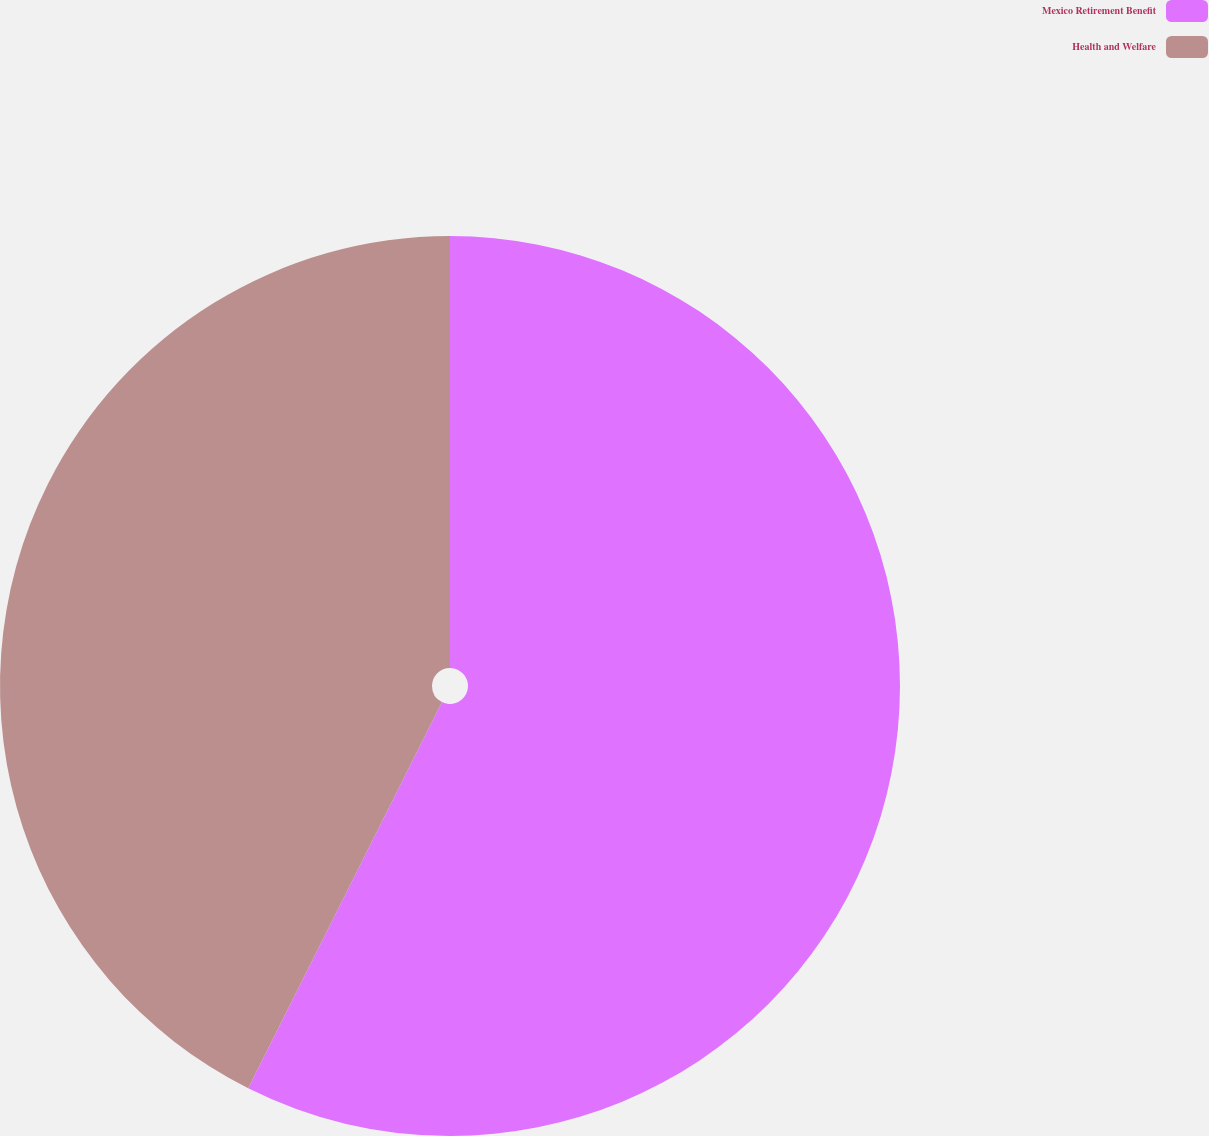Convert chart to OTSL. <chart><loc_0><loc_0><loc_500><loc_500><pie_chart><fcel>Mexico Retirement Benefit<fcel>Health and Welfare<nl><fcel>57.4%<fcel>42.6%<nl></chart> 